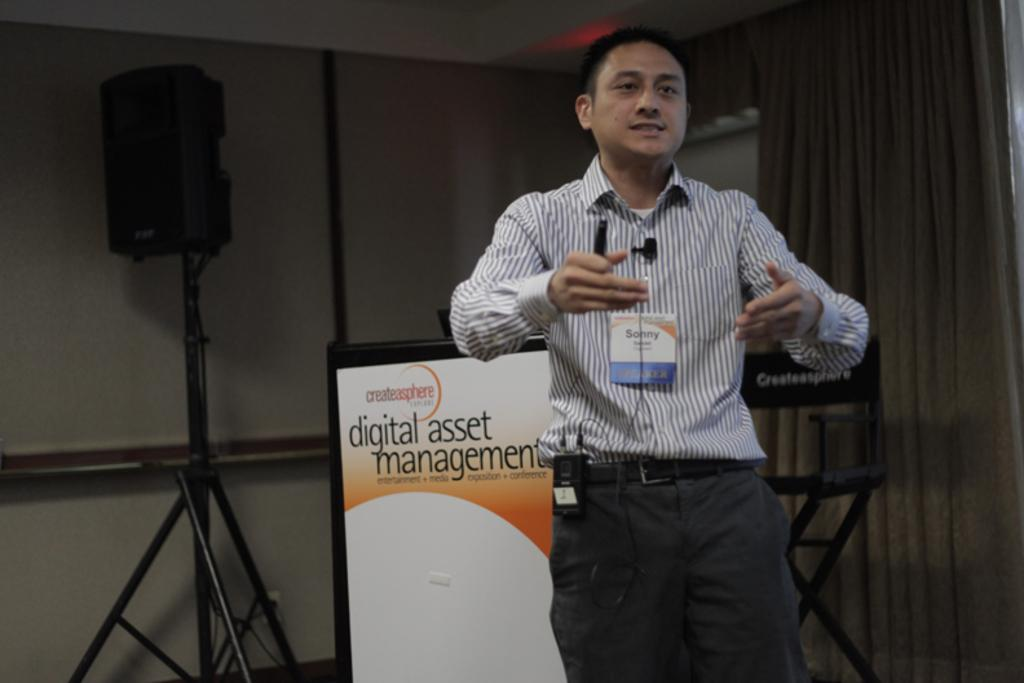What is the main subject of the image? There is a person standing and talking in the center of the image. What can be seen in the background of the image? There is a wall, a curtain, a board, and a speaker in the background of the image. What type of tin can be seen on the board in the image? There is no tin present on the board in the image. How does the person in the image show respect to the audience? The image does not provide information about the person's actions or intentions, so it cannot be determined if they are showing respect to the audience. 